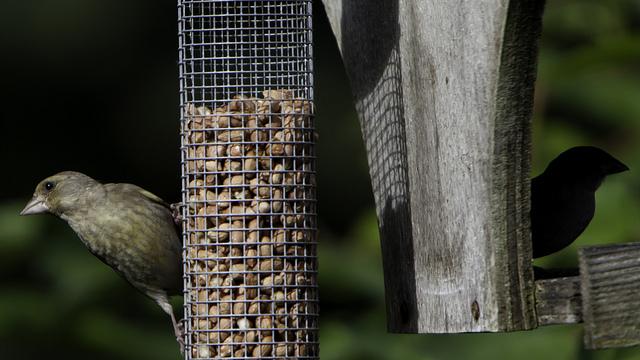Does this bird want to eat the nuts?
Concise answer only. Yes. What is the bird eating from?
Quick response, please. Feeder. What is the feed that the bird is eating?
Give a very brief answer. Nuts. What species of bird is on the left?
Give a very brief answer. Sparrow. How many birds are there?
Quick response, please. 2. What is the bird sitting on?
Write a very short answer. Feeder. What is the bird standing on?
Be succinct. Feeder. Why are there circular shapes in the background?
Be succinct. Acorns. What is the bird doing?
Concise answer only. Eating. 